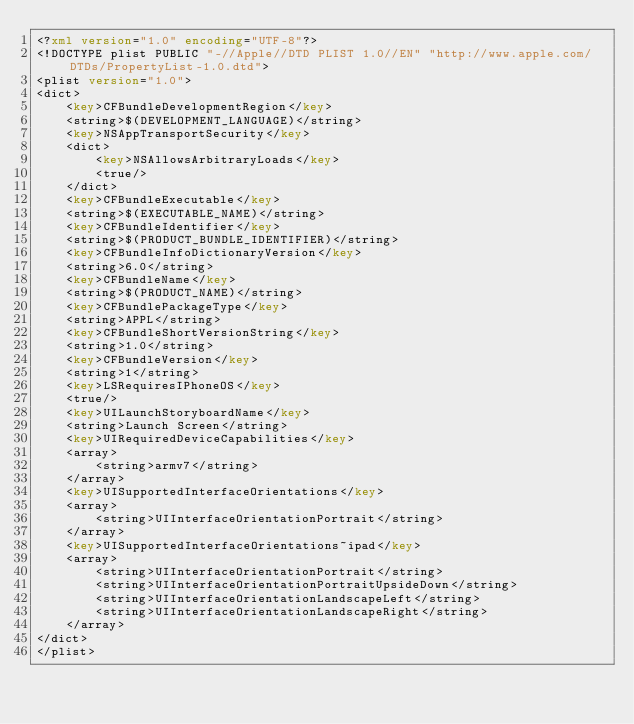Convert code to text. <code><loc_0><loc_0><loc_500><loc_500><_XML_><?xml version="1.0" encoding="UTF-8"?>
<!DOCTYPE plist PUBLIC "-//Apple//DTD PLIST 1.0//EN" "http://www.apple.com/DTDs/PropertyList-1.0.dtd">
<plist version="1.0">
<dict>
	<key>CFBundleDevelopmentRegion</key>
	<string>$(DEVELOPMENT_LANGUAGE)</string>
	<key>NSAppTransportSecurity</key>
	<dict>
		<key>NSAllowsArbitraryLoads</key>
		<true/>
	</dict>
	<key>CFBundleExecutable</key>
	<string>$(EXECUTABLE_NAME)</string>
	<key>CFBundleIdentifier</key>
	<string>$(PRODUCT_BUNDLE_IDENTIFIER)</string>
	<key>CFBundleInfoDictionaryVersion</key>
	<string>6.0</string>
	<key>CFBundleName</key>
	<string>$(PRODUCT_NAME)</string>
	<key>CFBundlePackageType</key>
	<string>APPL</string>
	<key>CFBundleShortVersionString</key>
	<string>1.0</string>
	<key>CFBundleVersion</key>
	<string>1</string>
	<key>LSRequiresIPhoneOS</key>
	<true/>
	<key>UILaunchStoryboardName</key>
	<string>Launch Screen</string>
	<key>UIRequiredDeviceCapabilities</key>
	<array>
		<string>armv7</string>
	</array>
	<key>UISupportedInterfaceOrientations</key>
	<array>
		<string>UIInterfaceOrientationPortrait</string>
	</array>
	<key>UISupportedInterfaceOrientations~ipad</key>
	<array>
		<string>UIInterfaceOrientationPortrait</string>
		<string>UIInterfaceOrientationPortraitUpsideDown</string>
		<string>UIInterfaceOrientationLandscapeLeft</string>
		<string>UIInterfaceOrientationLandscapeRight</string>
	</array>
</dict>
</plist>
</code> 